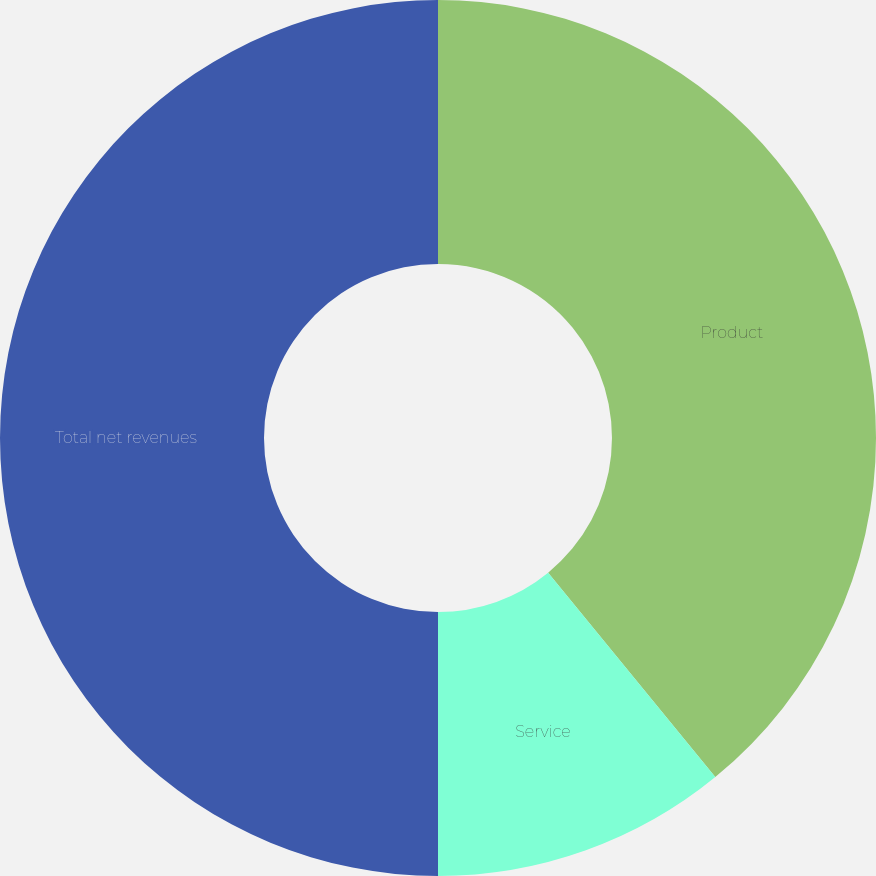Convert chart to OTSL. <chart><loc_0><loc_0><loc_500><loc_500><pie_chart><fcel>Product<fcel>Service<fcel>Total net revenues<nl><fcel>39.09%<fcel>10.91%<fcel>50.0%<nl></chart> 